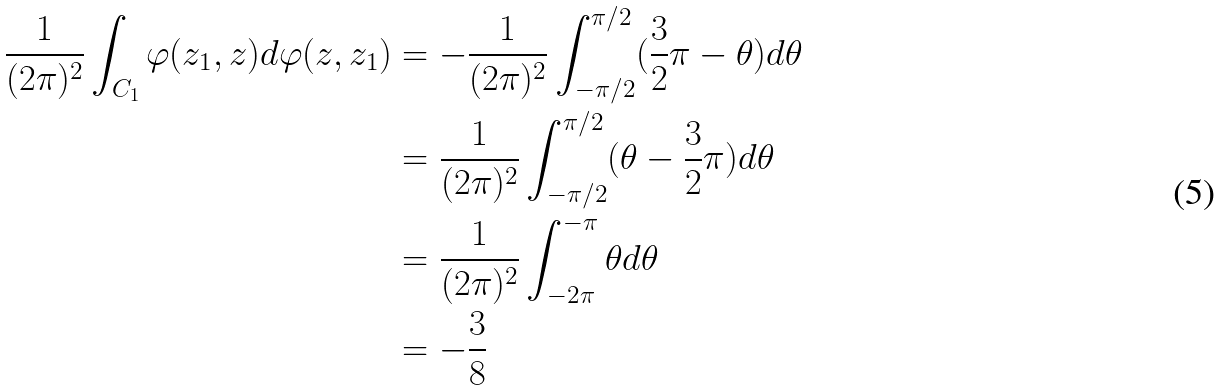<formula> <loc_0><loc_0><loc_500><loc_500>\frac { 1 } { ( 2 \pi ) ^ { 2 } } \int _ { C _ { 1 } } \varphi ( z _ { 1 } , z ) d \varphi ( z , z _ { 1 } ) & = - \frac { 1 } { ( 2 \pi ) ^ { 2 } } \int _ { - \pi / 2 } ^ { \pi / 2 } ( \frac { 3 } { 2 } \pi - \theta ) d \theta \\ & = \frac { 1 } { ( 2 \pi ) ^ { 2 } } \int _ { - \pi / 2 } ^ { \pi / 2 } ( \theta - \frac { 3 } { 2 } \pi ) d \theta \\ & = \frac { 1 } { ( 2 \pi ) ^ { 2 } } \int _ { - 2 \pi } ^ { - \pi } \theta d \theta \\ & = - \frac { 3 } { 8 }</formula> 